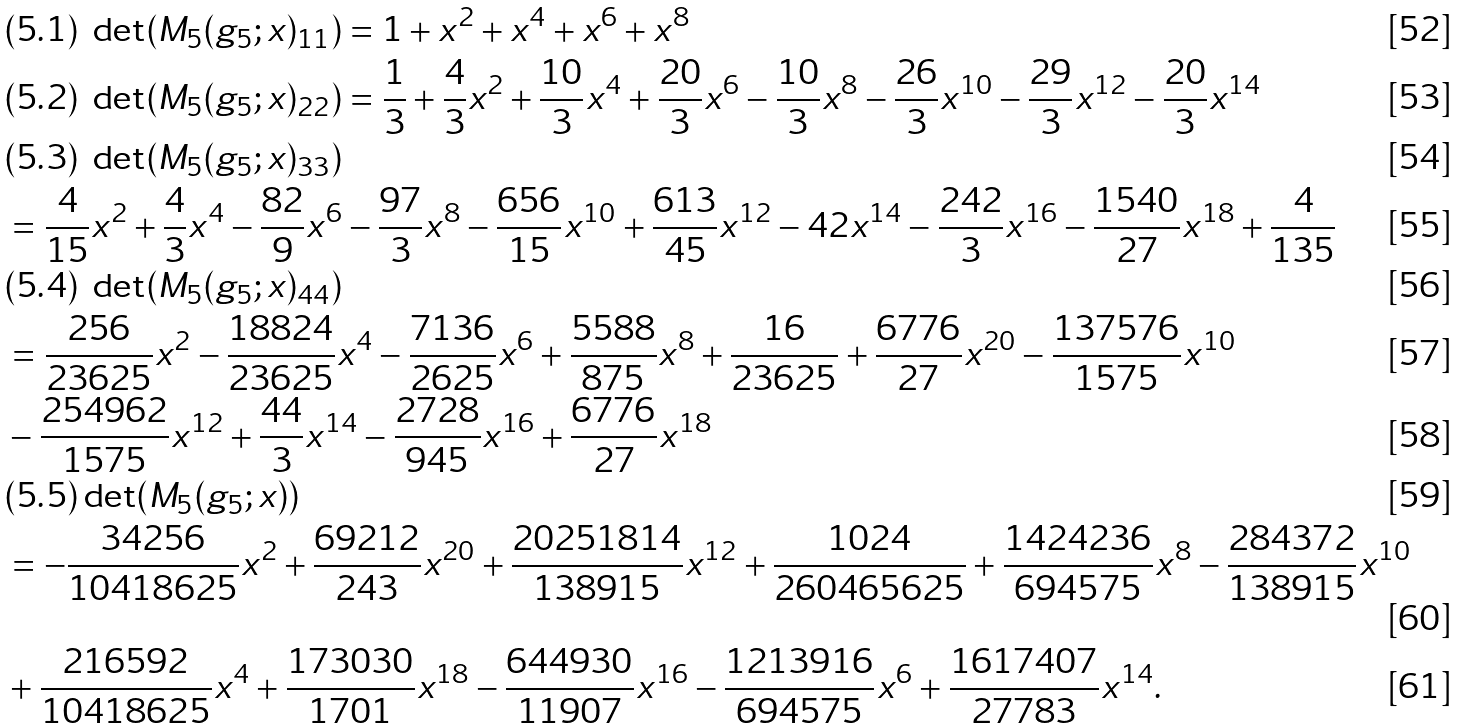<formula> <loc_0><loc_0><loc_500><loc_500>& ( 5 . 1 ) \ \det ( M _ { 5 } ( g _ { 5 } ; x ) _ { 1 1 } ) = 1 + x ^ { 2 } + x ^ { 4 } + x ^ { 6 } + x ^ { 8 } \\ & ( 5 . 2 ) \ \det ( M _ { 5 } ( g _ { 5 } ; x ) _ { 2 2 } ) = \frac { 1 } { 3 } + \frac { 4 } { 3 } x ^ { 2 } + \frac { 1 0 } { 3 } x ^ { 4 } + \frac { 2 0 } { 3 } x ^ { 6 } - \frac { 1 0 } { 3 } x ^ { 8 } - \frac { 2 6 } { 3 } x ^ { 1 0 } - \frac { 2 9 } { 3 } x ^ { 1 2 } - \frac { 2 0 } { 3 } x ^ { 1 4 } \\ & ( 5 . 3 ) \ \det ( M _ { 5 } ( g _ { 5 } ; x ) _ { 3 3 } ) \\ & = \frac { 4 } { 1 5 } x ^ { 2 } + \frac { 4 } { 3 } x ^ { 4 } - \frac { 8 2 } { 9 } x ^ { 6 } - \frac { 9 7 } { 3 } x ^ { 8 } - \frac { 6 5 6 } { 1 5 } x ^ { 1 0 } + \frac { 6 1 3 } { 4 5 } x ^ { 1 2 } - 4 2 x ^ { 1 4 } - \frac { 2 4 2 } { 3 } x ^ { 1 6 } - \frac { 1 5 4 0 } { 2 7 } x ^ { 1 8 } + \frac { 4 } { 1 3 5 } \\ & ( 5 . 4 ) \ \det ( M _ { 5 } ( g _ { 5 } ; x ) _ { 4 4 } ) \\ & = \frac { 2 5 6 } { 2 3 6 2 5 } x ^ { 2 } - \frac { 1 8 8 2 4 } { 2 3 6 2 5 } x ^ { 4 } - \frac { 7 1 3 6 } { 2 6 2 5 } x ^ { 6 } + \frac { 5 5 8 8 } { 8 7 5 } x ^ { 8 } + \frac { 1 6 } { 2 3 6 2 5 } + \frac { 6 7 7 6 } { 2 7 } x ^ { 2 0 } - \frac { 1 3 7 5 7 6 } { 1 5 7 5 } x ^ { 1 0 } \\ & - \frac { 2 5 4 9 6 2 } { 1 5 7 5 } x ^ { 1 2 } + \frac { 4 4 } { 3 } x ^ { 1 4 } - \frac { 2 7 2 8 } { 9 4 5 } x ^ { 1 6 } + \frac { 6 7 7 6 } { 2 7 } x ^ { 1 8 } \\ & ( 5 . 5 ) \det ( M _ { 5 } ( g _ { 5 } ; x ) ) \\ & = - \frac { 3 4 2 5 6 } { 1 0 4 1 8 6 2 5 } x ^ { 2 } + \frac { 6 9 2 1 2 } { 2 4 3 } x ^ { 2 0 } + \frac { 2 0 2 5 1 8 1 4 } { 1 3 8 9 1 5 } x ^ { 1 2 } + \frac { 1 0 2 4 } { 2 6 0 4 6 5 6 2 5 } + \frac { 1 4 2 4 2 3 6 } { 6 9 4 5 7 5 } x ^ { 8 } - \frac { 2 8 4 3 7 2 } { 1 3 8 9 1 5 } x ^ { 1 0 } \\ & + \frac { 2 1 6 5 9 2 } { 1 0 4 1 8 6 2 5 } x ^ { 4 } + \frac { 1 7 3 0 3 0 } { 1 7 0 1 } x ^ { 1 8 } - \frac { 6 4 4 9 3 0 } { 1 1 9 0 7 } x ^ { 1 6 } - \frac { 1 2 1 3 9 1 6 } { 6 9 4 5 7 5 } x ^ { 6 } + \frac { 1 6 1 7 4 0 7 } { 2 7 7 8 3 } x ^ { 1 4 } .</formula> 